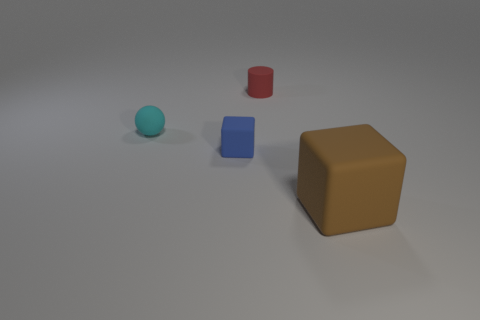Add 2 large shiny cubes. How many objects exist? 6 Subtract all blue cubes. How many cubes are left? 1 Subtract 1 spheres. How many spheres are left? 0 Add 1 blue objects. How many blue objects exist? 2 Subtract 0 cyan cylinders. How many objects are left? 4 Subtract all cylinders. How many objects are left? 3 Subtract all brown spheres. Subtract all red blocks. How many spheres are left? 1 Subtract all blue cylinders. How many blue cubes are left? 1 Subtract all tiny blocks. Subtract all blue things. How many objects are left? 2 Add 1 small objects. How many small objects are left? 4 